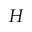<formula> <loc_0><loc_0><loc_500><loc_500>H</formula> 